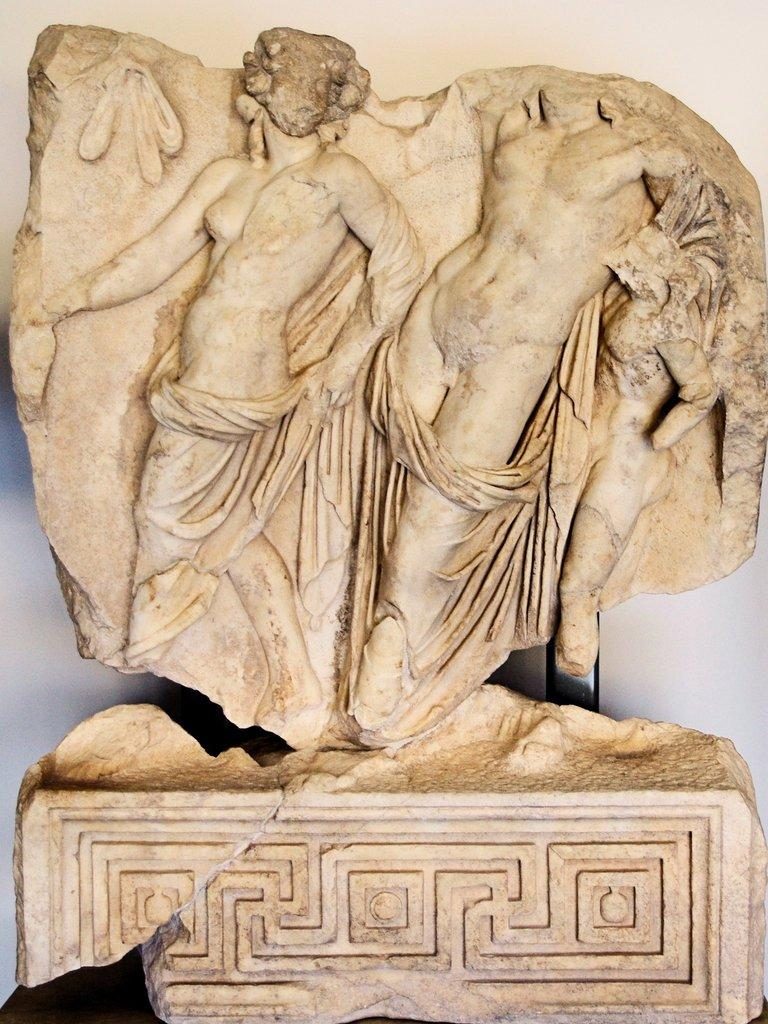What is the main subject in the image? There is a sculpture in the image. Can you describe the setting or background of the sculpture? There is a wall visible in the image, specifically on the backside of the sculpture. What type of spade is being used to dig around the sculpture in the image? There is no spade present in the image; it only features a sculpture and a wall. 